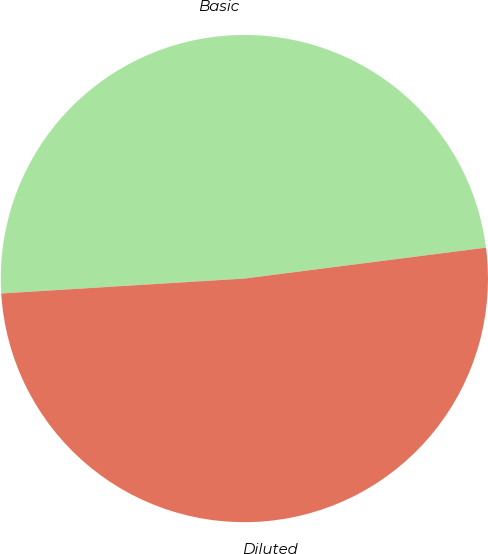<chart> <loc_0><loc_0><loc_500><loc_500><pie_chart><fcel>Basic<fcel>Diluted<nl><fcel>48.95%<fcel>51.05%<nl></chart> 